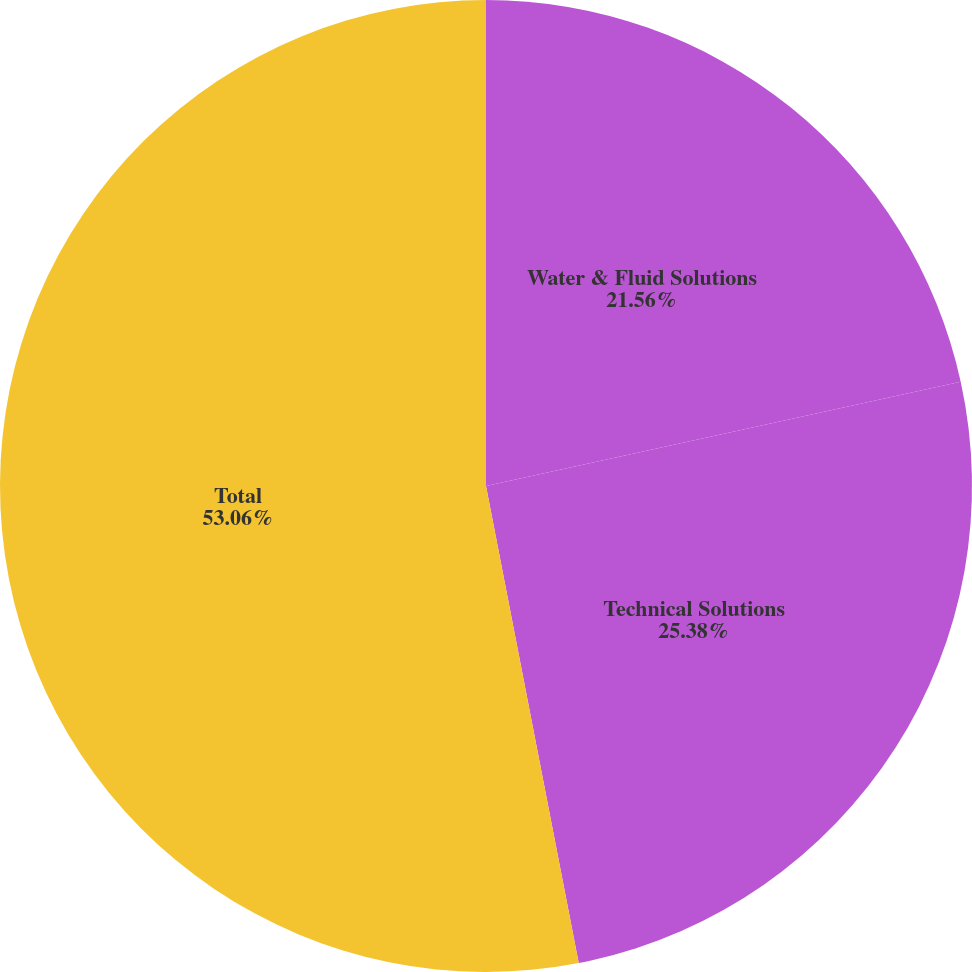Convert chart. <chart><loc_0><loc_0><loc_500><loc_500><pie_chart><fcel>Water & Fluid Solutions<fcel>Technical Solutions<fcel>Total<nl><fcel>21.56%<fcel>25.38%<fcel>53.05%<nl></chart> 